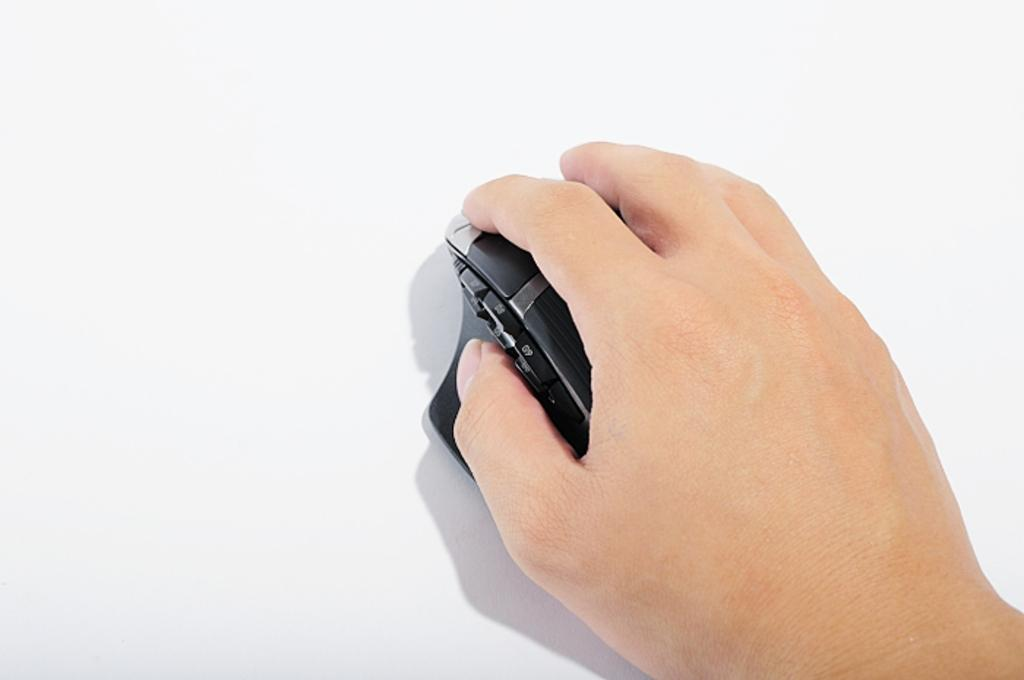What is the hand holding in the image? The hand is holding a black object in the image. What is the color of the majority of the image? The remaining portion of the image is in white color. How many lizards can be seen in the image? There are no lizards present in the image. What type of office equipment is visible in the image? There is no office equipment visible in the image. 